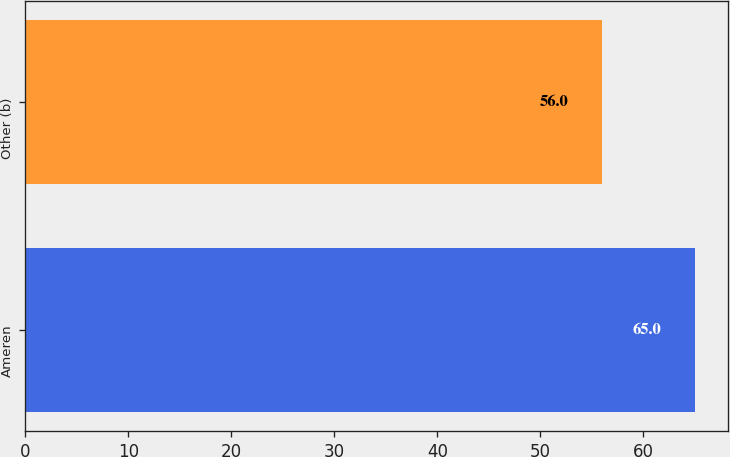Convert chart to OTSL. <chart><loc_0><loc_0><loc_500><loc_500><bar_chart><fcel>Ameren<fcel>Other (b)<nl><fcel>65<fcel>56<nl></chart> 